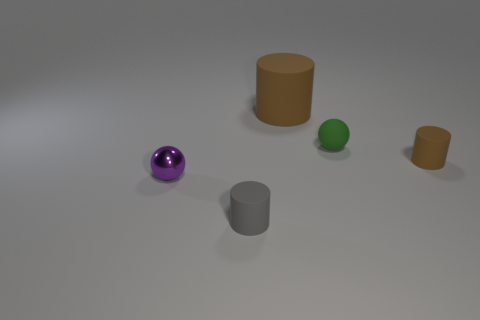The cylinder that is behind the tiny purple shiny thing and in front of the large brown rubber cylinder is what color?
Offer a terse response. Brown. Is the size of the thing that is in front of the purple metal thing the same as the small green rubber object?
Your answer should be compact. Yes. Is there a tiny green object on the left side of the brown rubber object that is in front of the large thing?
Your answer should be compact. Yes. What is the material of the green thing?
Offer a very short reply. Rubber. There is a purple metal object; are there any brown matte cylinders in front of it?
Your answer should be compact. No. What is the size of the other thing that is the same shape as the small metallic object?
Your response must be concise. Small. Are there an equal number of tiny purple metal objects that are right of the tiny purple ball and small matte cylinders to the right of the green thing?
Keep it short and to the point. No. What number of tiny brown matte spheres are there?
Your answer should be very brief. 0. Is the number of tiny gray things behind the green rubber object greater than the number of tiny green rubber balls?
Ensure brevity in your answer.  No. What is the thing in front of the shiny thing made of?
Your answer should be compact. Rubber. 